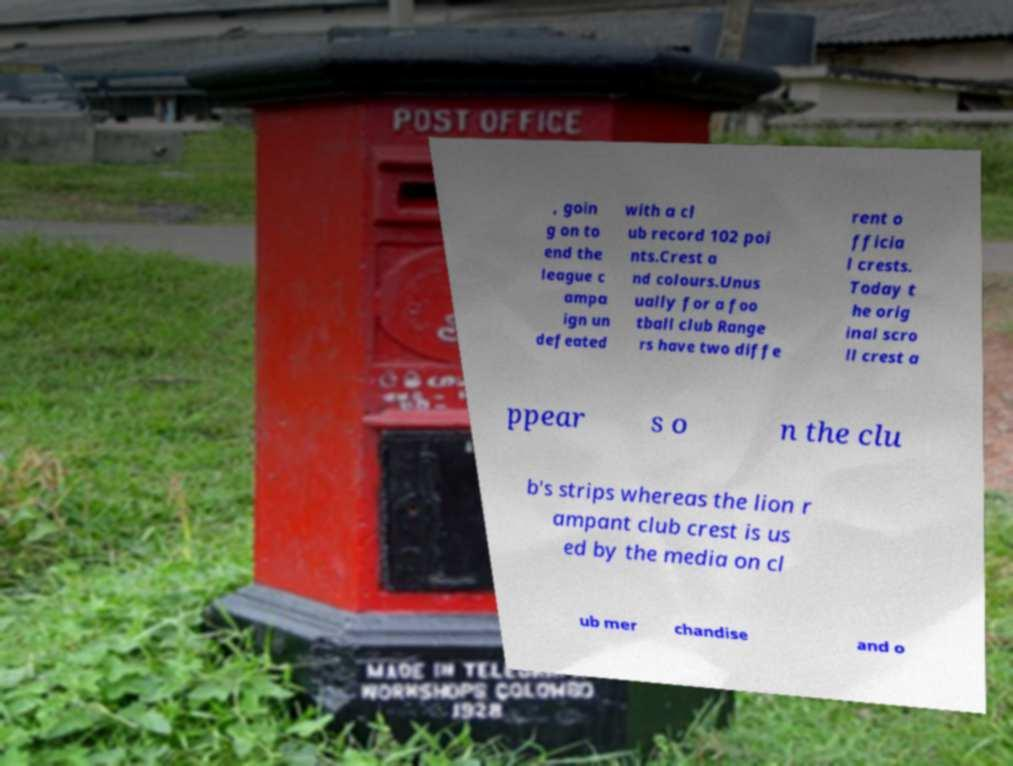Could you assist in decoding the text presented in this image and type it out clearly? , goin g on to end the league c ampa ign un defeated with a cl ub record 102 poi nts.Crest a nd colours.Unus ually for a foo tball club Range rs have two diffe rent o fficia l crests. Today t he orig inal scro ll crest a ppear s o n the clu b's strips whereas the lion r ampant club crest is us ed by the media on cl ub mer chandise and o 